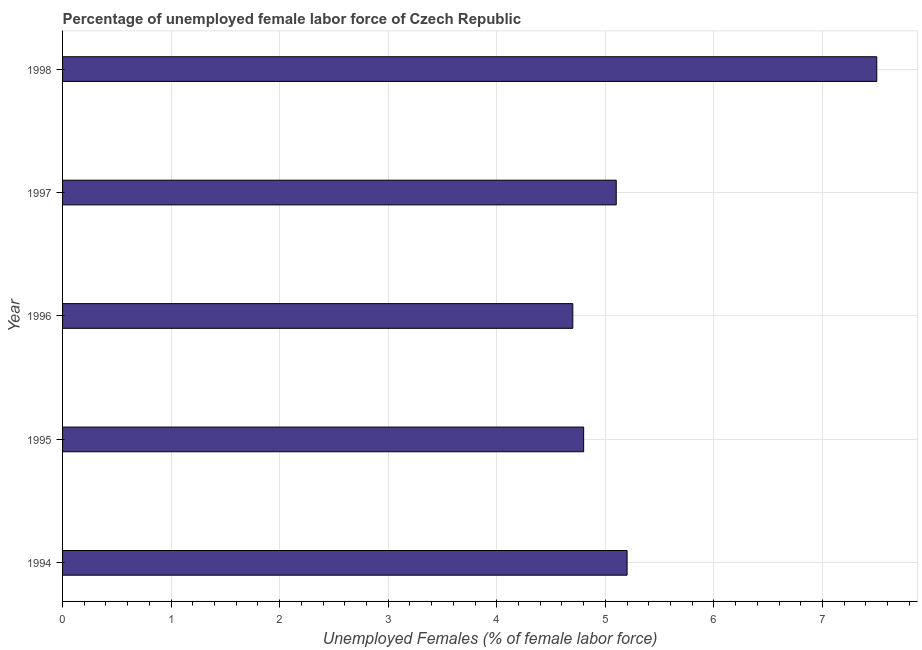Does the graph contain grids?
Keep it short and to the point. Yes. What is the title of the graph?
Keep it short and to the point. Percentage of unemployed female labor force of Czech Republic. What is the label or title of the X-axis?
Keep it short and to the point. Unemployed Females (% of female labor force). What is the label or title of the Y-axis?
Provide a short and direct response. Year. What is the total unemployed female labour force in 1997?
Ensure brevity in your answer.  5.1. Across all years, what is the minimum total unemployed female labour force?
Provide a succinct answer. 4.7. In which year was the total unemployed female labour force maximum?
Provide a short and direct response. 1998. In which year was the total unemployed female labour force minimum?
Offer a terse response. 1996. What is the sum of the total unemployed female labour force?
Give a very brief answer. 27.3. What is the difference between the total unemployed female labour force in 1994 and 1996?
Provide a succinct answer. 0.5. What is the average total unemployed female labour force per year?
Your response must be concise. 5.46. What is the median total unemployed female labour force?
Provide a short and direct response. 5.1. In how many years, is the total unemployed female labour force greater than 4.6 %?
Provide a succinct answer. 5. Do a majority of the years between 1998 and 1997 (inclusive) have total unemployed female labour force greater than 1.4 %?
Your answer should be compact. No. What is the ratio of the total unemployed female labour force in 1996 to that in 1997?
Offer a terse response. 0.92. Is the total unemployed female labour force in 1997 less than that in 1998?
Offer a terse response. Yes. Are the values on the major ticks of X-axis written in scientific E-notation?
Offer a very short reply. No. What is the Unemployed Females (% of female labor force) in 1994?
Provide a short and direct response. 5.2. What is the Unemployed Females (% of female labor force) of 1995?
Provide a succinct answer. 4.8. What is the Unemployed Females (% of female labor force) of 1996?
Offer a terse response. 4.7. What is the Unemployed Females (% of female labor force) of 1997?
Offer a terse response. 5.1. What is the Unemployed Females (% of female labor force) in 1998?
Ensure brevity in your answer.  7.5. What is the difference between the Unemployed Females (% of female labor force) in 1994 and 1995?
Your answer should be compact. 0.4. What is the difference between the Unemployed Females (% of female labor force) in 1994 and 1998?
Your answer should be very brief. -2.3. What is the difference between the Unemployed Females (% of female labor force) in 1996 and 1998?
Keep it short and to the point. -2.8. What is the difference between the Unemployed Females (% of female labor force) in 1997 and 1998?
Offer a terse response. -2.4. What is the ratio of the Unemployed Females (% of female labor force) in 1994 to that in 1995?
Provide a succinct answer. 1.08. What is the ratio of the Unemployed Females (% of female labor force) in 1994 to that in 1996?
Your answer should be compact. 1.11. What is the ratio of the Unemployed Females (% of female labor force) in 1994 to that in 1997?
Make the answer very short. 1.02. What is the ratio of the Unemployed Females (% of female labor force) in 1994 to that in 1998?
Make the answer very short. 0.69. What is the ratio of the Unemployed Females (% of female labor force) in 1995 to that in 1996?
Provide a succinct answer. 1.02. What is the ratio of the Unemployed Females (% of female labor force) in 1995 to that in 1997?
Give a very brief answer. 0.94. What is the ratio of the Unemployed Females (% of female labor force) in 1995 to that in 1998?
Your answer should be very brief. 0.64. What is the ratio of the Unemployed Females (% of female labor force) in 1996 to that in 1997?
Provide a short and direct response. 0.92. What is the ratio of the Unemployed Females (% of female labor force) in 1996 to that in 1998?
Ensure brevity in your answer.  0.63. What is the ratio of the Unemployed Females (% of female labor force) in 1997 to that in 1998?
Give a very brief answer. 0.68. 